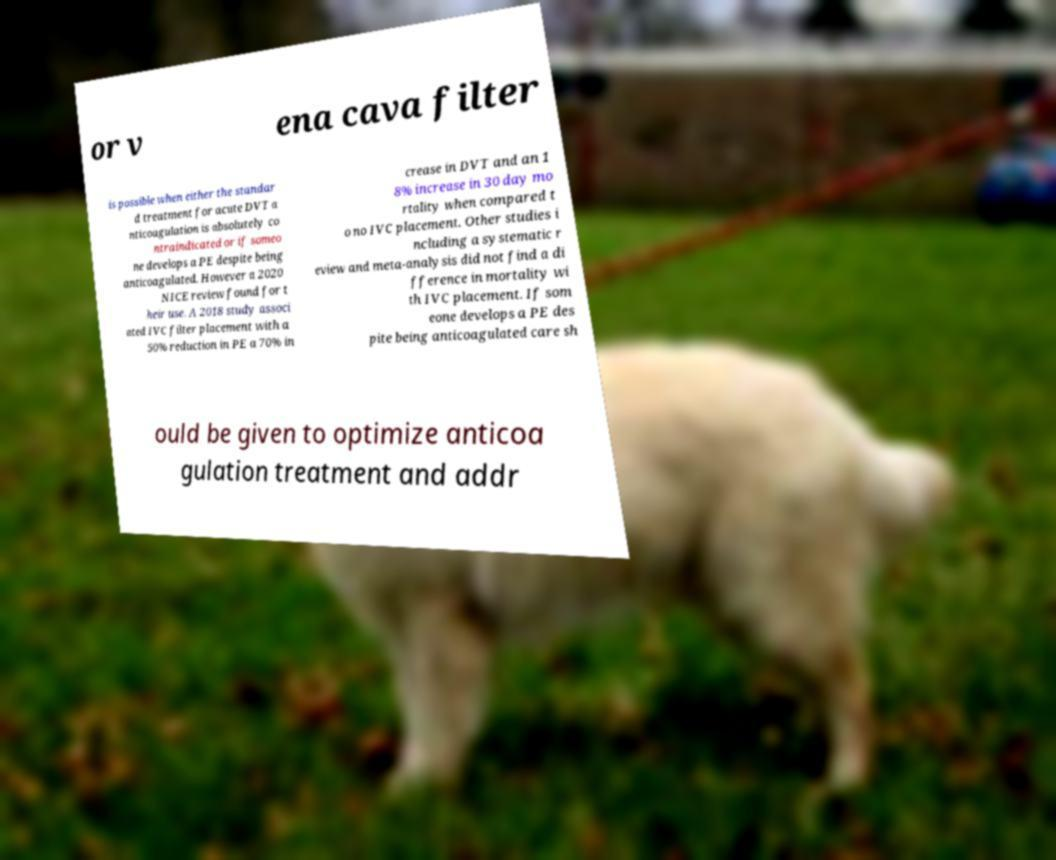Could you assist in decoding the text presented in this image and type it out clearly? or v ena cava filter is possible when either the standar d treatment for acute DVT a nticoagulation is absolutely co ntraindicated or if someo ne develops a PE despite being anticoagulated. However a 2020 NICE review found for t heir use. A 2018 study associ ated IVC filter placement with a 50% reduction in PE a 70% in crease in DVT and an 1 8% increase in 30 day mo rtality when compared t o no IVC placement. Other studies i ncluding a systematic r eview and meta-analysis did not find a di fference in mortality wi th IVC placement. If som eone develops a PE des pite being anticoagulated care sh ould be given to optimize anticoa gulation treatment and addr 